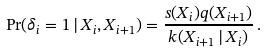Convert formula to latex. <formula><loc_0><loc_0><loc_500><loc_500>\Pr ( \delta _ { i } = 1 \, | \, X _ { i } , X _ { i + 1 } ) = \frac { s ( X _ { i } ) q ( X _ { i + 1 } ) } { k ( X _ { i + 1 } \, | \, X _ { i } ) } \, .</formula> 